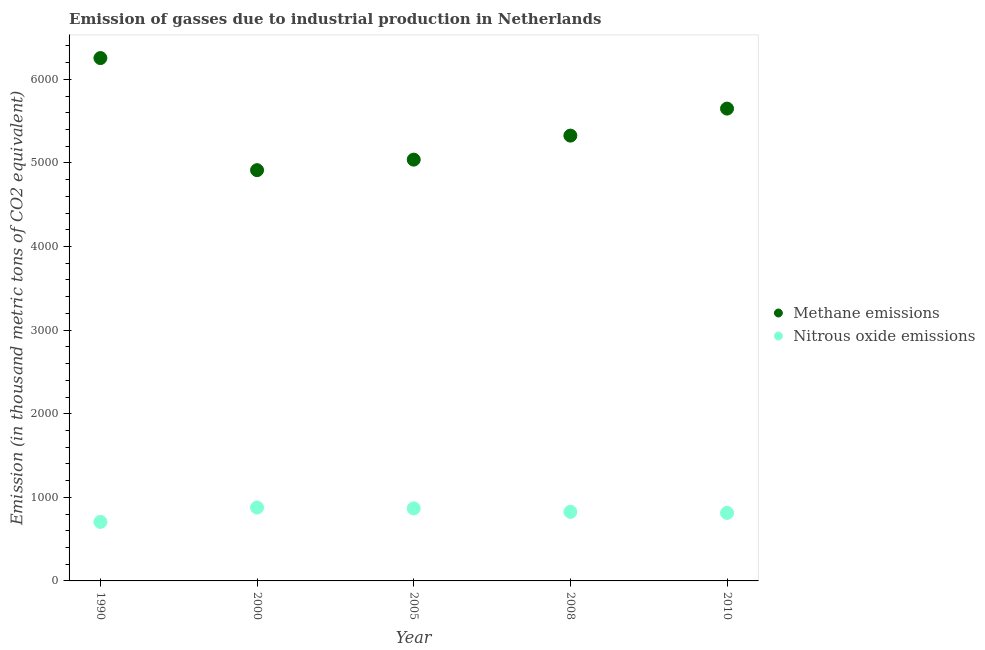How many different coloured dotlines are there?
Your response must be concise. 2. Is the number of dotlines equal to the number of legend labels?
Your response must be concise. Yes. What is the amount of methane emissions in 2005?
Provide a short and direct response. 5039.5. Across all years, what is the maximum amount of nitrous oxide emissions?
Ensure brevity in your answer.  878. Across all years, what is the minimum amount of methane emissions?
Make the answer very short. 4913.4. In which year was the amount of nitrous oxide emissions maximum?
Make the answer very short. 2000. In which year was the amount of nitrous oxide emissions minimum?
Offer a very short reply. 1990. What is the total amount of methane emissions in the graph?
Give a very brief answer. 2.72e+04. What is the difference between the amount of methane emissions in 2000 and that in 2005?
Your answer should be compact. -126.1. What is the difference between the amount of methane emissions in 2010 and the amount of nitrous oxide emissions in 2005?
Your answer should be very brief. 4782.2. What is the average amount of nitrous oxide emissions per year?
Give a very brief answer. 818.34. In the year 2008, what is the difference between the amount of nitrous oxide emissions and amount of methane emissions?
Your answer should be very brief. -4500.4. In how many years, is the amount of nitrous oxide emissions greater than 400 thousand metric tons?
Offer a very short reply. 5. What is the ratio of the amount of nitrous oxide emissions in 1990 to that in 2005?
Your answer should be very brief. 0.81. Is the amount of nitrous oxide emissions in 1990 less than that in 2008?
Your answer should be very brief. Yes. What is the difference between the highest and the second highest amount of nitrous oxide emissions?
Your answer should be very brief. 10.2. What is the difference between the highest and the lowest amount of methane emissions?
Provide a succinct answer. 1341. In how many years, is the amount of nitrous oxide emissions greater than the average amount of nitrous oxide emissions taken over all years?
Ensure brevity in your answer.  3. Is the sum of the amount of nitrous oxide emissions in 2005 and 2008 greater than the maximum amount of methane emissions across all years?
Give a very brief answer. No. Does the amount of nitrous oxide emissions monotonically increase over the years?
Offer a very short reply. No. Is the amount of methane emissions strictly greater than the amount of nitrous oxide emissions over the years?
Your answer should be compact. Yes. Is the amount of nitrous oxide emissions strictly less than the amount of methane emissions over the years?
Offer a terse response. Yes. How many dotlines are there?
Your answer should be compact. 2. How many years are there in the graph?
Offer a very short reply. 5. What is the difference between two consecutive major ticks on the Y-axis?
Provide a succinct answer. 1000. Are the values on the major ticks of Y-axis written in scientific E-notation?
Your answer should be compact. No. Does the graph contain grids?
Your response must be concise. No. Where does the legend appear in the graph?
Give a very brief answer. Center right. How many legend labels are there?
Make the answer very short. 2. What is the title of the graph?
Offer a terse response. Emission of gasses due to industrial production in Netherlands. What is the label or title of the X-axis?
Your answer should be compact. Year. What is the label or title of the Y-axis?
Ensure brevity in your answer.  Emission (in thousand metric tons of CO2 equivalent). What is the Emission (in thousand metric tons of CO2 equivalent) of Methane emissions in 1990?
Your answer should be very brief. 6254.4. What is the Emission (in thousand metric tons of CO2 equivalent) in Nitrous oxide emissions in 1990?
Offer a very short reply. 705.9. What is the Emission (in thousand metric tons of CO2 equivalent) of Methane emissions in 2000?
Your answer should be compact. 4913.4. What is the Emission (in thousand metric tons of CO2 equivalent) in Nitrous oxide emissions in 2000?
Your answer should be very brief. 878. What is the Emission (in thousand metric tons of CO2 equivalent) of Methane emissions in 2005?
Ensure brevity in your answer.  5039.5. What is the Emission (in thousand metric tons of CO2 equivalent) of Nitrous oxide emissions in 2005?
Your answer should be very brief. 867.8. What is the Emission (in thousand metric tons of CO2 equivalent) in Methane emissions in 2008?
Ensure brevity in your answer.  5326.8. What is the Emission (in thousand metric tons of CO2 equivalent) of Nitrous oxide emissions in 2008?
Offer a very short reply. 826.4. What is the Emission (in thousand metric tons of CO2 equivalent) of Methane emissions in 2010?
Offer a terse response. 5650. What is the Emission (in thousand metric tons of CO2 equivalent) in Nitrous oxide emissions in 2010?
Your answer should be compact. 813.6. Across all years, what is the maximum Emission (in thousand metric tons of CO2 equivalent) of Methane emissions?
Your answer should be very brief. 6254.4. Across all years, what is the maximum Emission (in thousand metric tons of CO2 equivalent) in Nitrous oxide emissions?
Your response must be concise. 878. Across all years, what is the minimum Emission (in thousand metric tons of CO2 equivalent) of Methane emissions?
Make the answer very short. 4913.4. Across all years, what is the minimum Emission (in thousand metric tons of CO2 equivalent) of Nitrous oxide emissions?
Provide a succinct answer. 705.9. What is the total Emission (in thousand metric tons of CO2 equivalent) in Methane emissions in the graph?
Give a very brief answer. 2.72e+04. What is the total Emission (in thousand metric tons of CO2 equivalent) in Nitrous oxide emissions in the graph?
Make the answer very short. 4091.7. What is the difference between the Emission (in thousand metric tons of CO2 equivalent) in Methane emissions in 1990 and that in 2000?
Your answer should be compact. 1341. What is the difference between the Emission (in thousand metric tons of CO2 equivalent) in Nitrous oxide emissions in 1990 and that in 2000?
Your answer should be compact. -172.1. What is the difference between the Emission (in thousand metric tons of CO2 equivalent) of Methane emissions in 1990 and that in 2005?
Keep it short and to the point. 1214.9. What is the difference between the Emission (in thousand metric tons of CO2 equivalent) in Nitrous oxide emissions in 1990 and that in 2005?
Offer a very short reply. -161.9. What is the difference between the Emission (in thousand metric tons of CO2 equivalent) of Methane emissions in 1990 and that in 2008?
Provide a succinct answer. 927.6. What is the difference between the Emission (in thousand metric tons of CO2 equivalent) of Nitrous oxide emissions in 1990 and that in 2008?
Provide a succinct answer. -120.5. What is the difference between the Emission (in thousand metric tons of CO2 equivalent) in Methane emissions in 1990 and that in 2010?
Provide a succinct answer. 604.4. What is the difference between the Emission (in thousand metric tons of CO2 equivalent) in Nitrous oxide emissions in 1990 and that in 2010?
Your answer should be compact. -107.7. What is the difference between the Emission (in thousand metric tons of CO2 equivalent) in Methane emissions in 2000 and that in 2005?
Make the answer very short. -126.1. What is the difference between the Emission (in thousand metric tons of CO2 equivalent) of Methane emissions in 2000 and that in 2008?
Your response must be concise. -413.4. What is the difference between the Emission (in thousand metric tons of CO2 equivalent) in Nitrous oxide emissions in 2000 and that in 2008?
Provide a succinct answer. 51.6. What is the difference between the Emission (in thousand metric tons of CO2 equivalent) in Methane emissions in 2000 and that in 2010?
Provide a succinct answer. -736.6. What is the difference between the Emission (in thousand metric tons of CO2 equivalent) in Nitrous oxide emissions in 2000 and that in 2010?
Ensure brevity in your answer.  64.4. What is the difference between the Emission (in thousand metric tons of CO2 equivalent) of Methane emissions in 2005 and that in 2008?
Your response must be concise. -287.3. What is the difference between the Emission (in thousand metric tons of CO2 equivalent) of Nitrous oxide emissions in 2005 and that in 2008?
Offer a very short reply. 41.4. What is the difference between the Emission (in thousand metric tons of CO2 equivalent) in Methane emissions in 2005 and that in 2010?
Ensure brevity in your answer.  -610.5. What is the difference between the Emission (in thousand metric tons of CO2 equivalent) in Nitrous oxide emissions in 2005 and that in 2010?
Your answer should be very brief. 54.2. What is the difference between the Emission (in thousand metric tons of CO2 equivalent) of Methane emissions in 2008 and that in 2010?
Your answer should be very brief. -323.2. What is the difference between the Emission (in thousand metric tons of CO2 equivalent) in Methane emissions in 1990 and the Emission (in thousand metric tons of CO2 equivalent) in Nitrous oxide emissions in 2000?
Give a very brief answer. 5376.4. What is the difference between the Emission (in thousand metric tons of CO2 equivalent) of Methane emissions in 1990 and the Emission (in thousand metric tons of CO2 equivalent) of Nitrous oxide emissions in 2005?
Your answer should be compact. 5386.6. What is the difference between the Emission (in thousand metric tons of CO2 equivalent) of Methane emissions in 1990 and the Emission (in thousand metric tons of CO2 equivalent) of Nitrous oxide emissions in 2008?
Provide a succinct answer. 5428. What is the difference between the Emission (in thousand metric tons of CO2 equivalent) of Methane emissions in 1990 and the Emission (in thousand metric tons of CO2 equivalent) of Nitrous oxide emissions in 2010?
Offer a terse response. 5440.8. What is the difference between the Emission (in thousand metric tons of CO2 equivalent) in Methane emissions in 2000 and the Emission (in thousand metric tons of CO2 equivalent) in Nitrous oxide emissions in 2005?
Keep it short and to the point. 4045.6. What is the difference between the Emission (in thousand metric tons of CO2 equivalent) of Methane emissions in 2000 and the Emission (in thousand metric tons of CO2 equivalent) of Nitrous oxide emissions in 2008?
Your answer should be compact. 4087. What is the difference between the Emission (in thousand metric tons of CO2 equivalent) of Methane emissions in 2000 and the Emission (in thousand metric tons of CO2 equivalent) of Nitrous oxide emissions in 2010?
Provide a succinct answer. 4099.8. What is the difference between the Emission (in thousand metric tons of CO2 equivalent) of Methane emissions in 2005 and the Emission (in thousand metric tons of CO2 equivalent) of Nitrous oxide emissions in 2008?
Offer a very short reply. 4213.1. What is the difference between the Emission (in thousand metric tons of CO2 equivalent) of Methane emissions in 2005 and the Emission (in thousand metric tons of CO2 equivalent) of Nitrous oxide emissions in 2010?
Your response must be concise. 4225.9. What is the difference between the Emission (in thousand metric tons of CO2 equivalent) in Methane emissions in 2008 and the Emission (in thousand metric tons of CO2 equivalent) in Nitrous oxide emissions in 2010?
Provide a succinct answer. 4513.2. What is the average Emission (in thousand metric tons of CO2 equivalent) of Methane emissions per year?
Offer a very short reply. 5436.82. What is the average Emission (in thousand metric tons of CO2 equivalent) in Nitrous oxide emissions per year?
Provide a short and direct response. 818.34. In the year 1990, what is the difference between the Emission (in thousand metric tons of CO2 equivalent) in Methane emissions and Emission (in thousand metric tons of CO2 equivalent) in Nitrous oxide emissions?
Offer a very short reply. 5548.5. In the year 2000, what is the difference between the Emission (in thousand metric tons of CO2 equivalent) of Methane emissions and Emission (in thousand metric tons of CO2 equivalent) of Nitrous oxide emissions?
Your answer should be compact. 4035.4. In the year 2005, what is the difference between the Emission (in thousand metric tons of CO2 equivalent) of Methane emissions and Emission (in thousand metric tons of CO2 equivalent) of Nitrous oxide emissions?
Provide a succinct answer. 4171.7. In the year 2008, what is the difference between the Emission (in thousand metric tons of CO2 equivalent) in Methane emissions and Emission (in thousand metric tons of CO2 equivalent) in Nitrous oxide emissions?
Your answer should be compact. 4500.4. In the year 2010, what is the difference between the Emission (in thousand metric tons of CO2 equivalent) in Methane emissions and Emission (in thousand metric tons of CO2 equivalent) in Nitrous oxide emissions?
Give a very brief answer. 4836.4. What is the ratio of the Emission (in thousand metric tons of CO2 equivalent) of Methane emissions in 1990 to that in 2000?
Your answer should be compact. 1.27. What is the ratio of the Emission (in thousand metric tons of CO2 equivalent) of Nitrous oxide emissions in 1990 to that in 2000?
Offer a terse response. 0.8. What is the ratio of the Emission (in thousand metric tons of CO2 equivalent) of Methane emissions in 1990 to that in 2005?
Keep it short and to the point. 1.24. What is the ratio of the Emission (in thousand metric tons of CO2 equivalent) in Nitrous oxide emissions in 1990 to that in 2005?
Your answer should be compact. 0.81. What is the ratio of the Emission (in thousand metric tons of CO2 equivalent) in Methane emissions in 1990 to that in 2008?
Your answer should be very brief. 1.17. What is the ratio of the Emission (in thousand metric tons of CO2 equivalent) of Nitrous oxide emissions in 1990 to that in 2008?
Provide a short and direct response. 0.85. What is the ratio of the Emission (in thousand metric tons of CO2 equivalent) in Methane emissions in 1990 to that in 2010?
Offer a very short reply. 1.11. What is the ratio of the Emission (in thousand metric tons of CO2 equivalent) in Nitrous oxide emissions in 1990 to that in 2010?
Make the answer very short. 0.87. What is the ratio of the Emission (in thousand metric tons of CO2 equivalent) in Methane emissions in 2000 to that in 2005?
Offer a very short reply. 0.97. What is the ratio of the Emission (in thousand metric tons of CO2 equivalent) in Nitrous oxide emissions in 2000 to that in 2005?
Your answer should be very brief. 1.01. What is the ratio of the Emission (in thousand metric tons of CO2 equivalent) in Methane emissions in 2000 to that in 2008?
Your response must be concise. 0.92. What is the ratio of the Emission (in thousand metric tons of CO2 equivalent) of Nitrous oxide emissions in 2000 to that in 2008?
Offer a terse response. 1.06. What is the ratio of the Emission (in thousand metric tons of CO2 equivalent) in Methane emissions in 2000 to that in 2010?
Give a very brief answer. 0.87. What is the ratio of the Emission (in thousand metric tons of CO2 equivalent) in Nitrous oxide emissions in 2000 to that in 2010?
Your answer should be compact. 1.08. What is the ratio of the Emission (in thousand metric tons of CO2 equivalent) of Methane emissions in 2005 to that in 2008?
Make the answer very short. 0.95. What is the ratio of the Emission (in thousand metric tons of CO2 equivalent) of Nitrous oxide emissions in 2005 to that in 2008?
Keep it short and to the point. 1.05. What is the ratio of the Emission (in thousand metric tons of CO2 equivalent) of Methane emissions in 2005 to that in 2010?
Provide a succinct answer. 0.89. What is the ratio of the Emission (in thousand metric tons of CO2 equivalent) of Nitrous oxide emissions in 2005 to that in 2010?
Give a very brief answer. 1.07. What is the ratio of the Emission (in thousand metric tons of CO2 equivalent) in Methane emissions in 2008 to that in 2010?
Offer a very short reply. 0.94. What is the ratio of the Emission (in thousand metric tons of CO2 equivalent) of Nitrous oxide emissions in 2008 to that in 2010?
Your answer should be very brief. 1.02. What is the difference between the highest and the second highest Emission (in thousand metric tons of CO2 equivalent) of Methane emissions?
Keep it short and to the point. 604.4. What is the difference between the highest and the lowest Emission (in thousand metric tons of CO2 equivalent) in Methane emissions?
Your response must be concise. 1341. What is the difference between the highest and the lowest Emission (in thousand metric tons of CO2 equivalent) in Nitrous oxide emissions?
Offer a terse response. 172.1. 